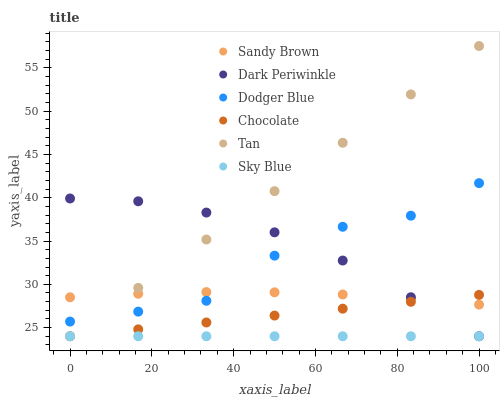Does Sky Blue have the minimum area under the curve?
Answer yes or no. Yes. Does Tan have the maximum area under the curve?
Answer yes or no. Yes. Does Dodger Blue have the minimum area under the curve?
Answer yes or no. No. Does Dodger Blue have the maximum area under the curve?
Answer yes or no. No. Is Sky Blue the smoothest?
Answer yes or no. Yes. Is Dodger Blue the roughest?
Answer yes or no. Yes. Is Dodger Blue the smoothest?
Answer yes or no. No. Is Sky Blue the roughest?
Answer yes or no. No. Does Chocolate have the lowest value?
Answer yes or no. Yes. Does Dodger Blue have the lowest value?
Answer yes or no. No. Does Tan have the highest value?
Answer yes or no. Yes. Does Dodger Blue have the highest value?
Answer yes or no. No. Is Sky Blue less than Sandy Brown?
Answer yes or no. Yes. Is Dodger Blue greater than Sky Blue?
Answer yes or no. Yes. Does Sandy Brown intersect Dark Periwinkle?
Answer yes or no. Yes. Is Sandy Brown less than Dark Periwinkle?
Answer yes or no. No. Is Sandy Brown greater than Dark Periwinkle?
Answer yes or no. No. Does Sky Blue intersect Sandy Brown?
Answer yes or no. No. 